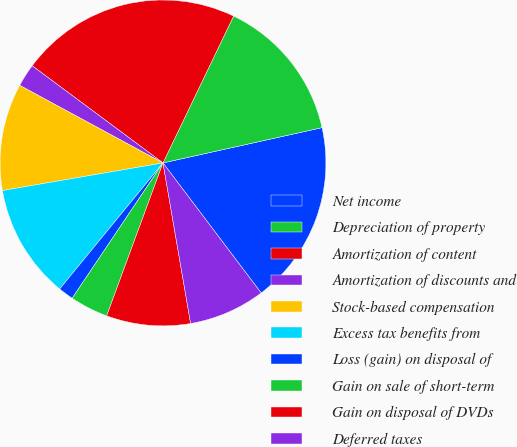Convert chart to OTSL. <chart><loc_0><loc_0><loc_500><loc_500><pie_chart><fcel>Net income<fcel>Depreciation of property<fcel>Amortization of content<fcel>Amortization of discounts and<fcel>Stock-based compensation<fcel>Excess tax benefits from<fcel>Loss (gain) on disposal of<fcel>Gain on sale of short-term<fcel>Gain on disposal of DVDs<fcel>Deferred taxes<nl><fcel>18.18%<fcel>14.39%<fcel>21.97%<fcel>2.27%<fcel>10.61%<fcel>11.36%<fcel>1.52%<fcel>3.79%<fcel>8.33%<fcel>7.58%<nl></chart> 